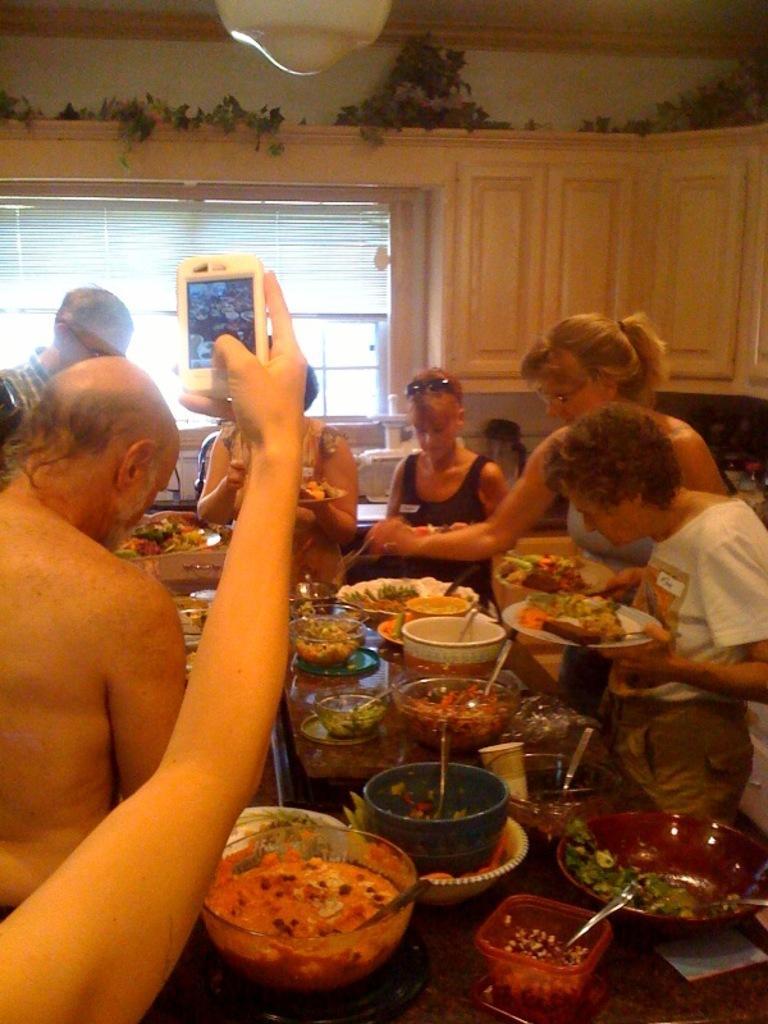Can you describe this image briefly? Here in this picture we can see number of people present and in between them we can see a table, on which we can see number of bowls and plates full of food present and in the front we can see a hand with mobile phone in hand and capturing pictures and behind them we can see window flaps present on the windows and beside that we can see cup boards present. 